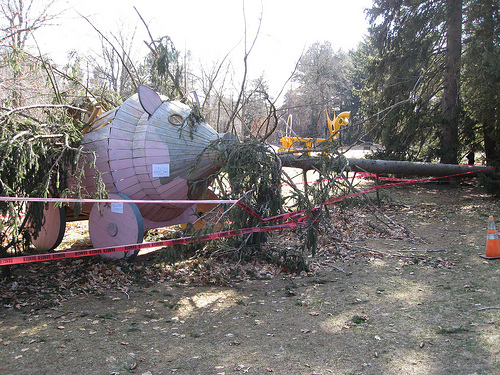<image>
Can you confirm if the giraffe is next to the rat? No. The giraffe is not positioned next to the rat. They are located in different areas of the scene. 